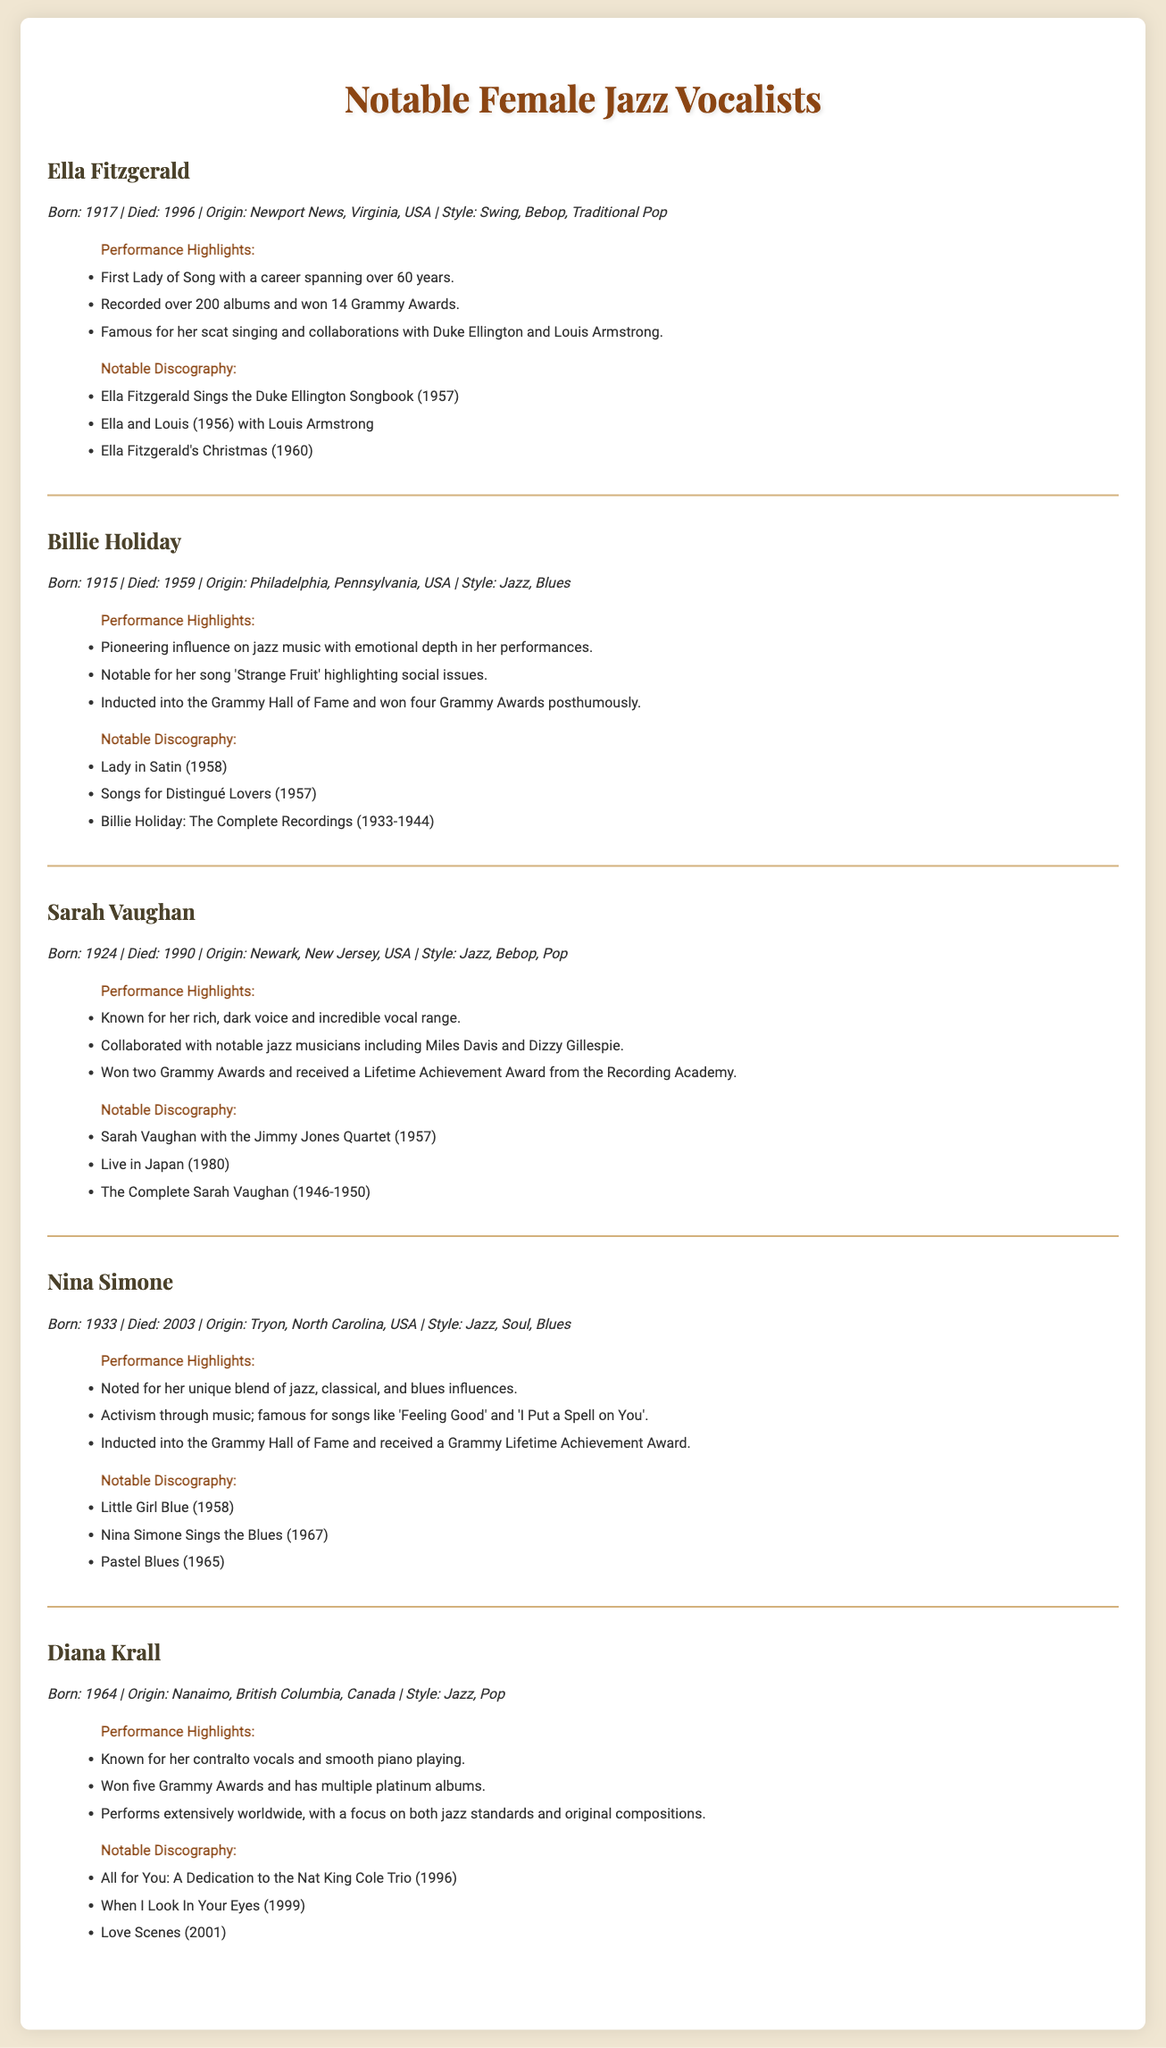What year was Ella Fitzgerald born? Ella Fitzgerald was born in 1917, as stated in her profile.
Answer: 1917 How many Grammy Awards did Billie Holiday win posthumously? The document indicates that Billie Holiday won four Grammy Awards posthumously.
Answer: four Which vocalist is known for the song 'Strange Fruit'? The document highlights that Billie Holiday is notable for her song 'Strange Fruit'.
Answer: Billie Holiday Which artist created the album "Nina Simone Sings the Blues"? The notable discography lists "Nina Simone Sings the Blues" as an album by Nina Simone.
Answer: Nina Simone Which female jazz vocalist performed extensively worldwide? According to her performance highlights, Diana Krall performs extensively worldwide.
Answer: Diana Krall What style of music is Sarah Vaughan associated with? Sarah Vaughan's profile mentions she is associated with Jazz, Bebop, and Pop.
Answer: Jazz, Bebop, Pop How many albums did Ella Fitzgerald record? The document states that Ella Fitzgerald recorded over 200 albums.
Answer: over 200 What is the origin of Nina Simone? The profile section indicates that Nina Simone was from Tryon, North Carolina, USA.
Answer: Tryon, North Carolina, USA Which vocalist is known for scat singing? The document mentions that Ella Fitzgerald is famous for her scat singing.
Answer: Ella Fitzgerald 